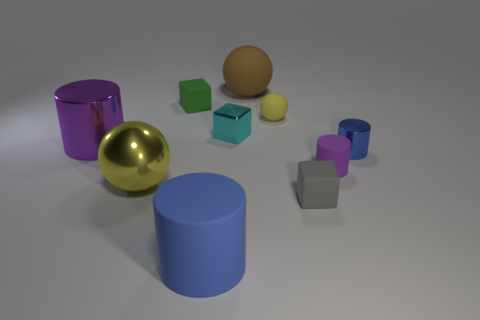What number of rubber objects are either gray cubes or cylinders?
Make the answer very short. 3. Are any big gray rubber things visible?
Offer a very short reply. No. There is a rubber cylinder behind the large sphere in front of the small blue cylinder; what color is it?
Provide a short and direct response. Purple. What number of other objects are the same color as the small sphere?
Keep it short and to the point. 1. How many objects are big cyan shiny things or blue things that are behind the small purple rubber cylinder?
Provide a succinct answer. 1. What is the color of the tiny matte cube that is in front of the tiny yellow rubber thing?
Keep it short and to the point. Gray. What shape is the tiny green object?
Ensure brevity in your answer.  Cube. What is the material of the small thing that is in front of the shiny ball that is in front of the green object?
Your response must be concise. Rubber. What number of other things are the same material as the tiny blue cylinder?
Make the answer very short. 3. There is a ball that is the same size as the gray cube; what is its material?
Your answer should be compact. Rubber. 